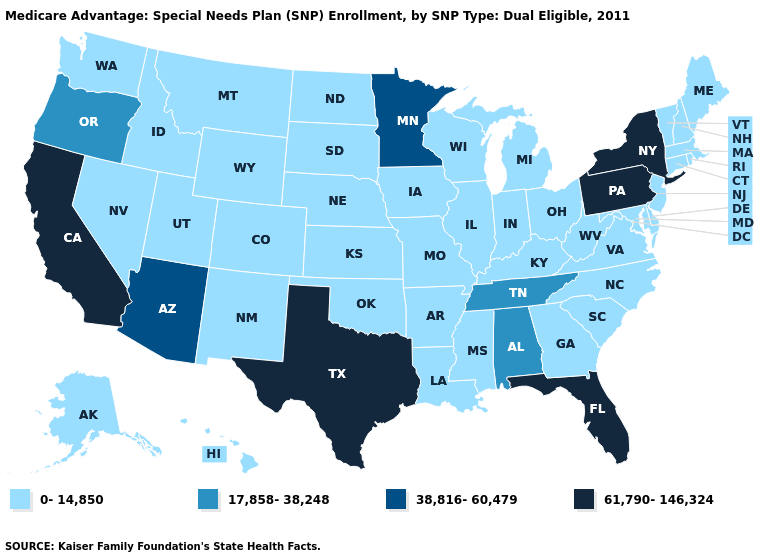Which states have the highest value in the USA?
Quick response, please. California, Florida, New York, Pennsylvania, Texas. Which states have the highest value in the USA?
Keep it brief. California, Florida, New York, Pennsylvania, Texas. Does Pennsylvania have the highest value in the Northeast?
Write a very short answer. Yes. Does North Carolina have a higher value than New Mexico?
Quick response, please. No. Name the states that have a value in the range 17,858-38,248?
Short answer required. Alabama, Oregon, Tennessee. Name the states that have a value in the range 17,858-38,248?
Keep it brief. Alabama, Oregon, Tennessee. Does Ohio have a higher value than Montana?
Keep it brief. No. What is the value of South Dakota?
Give a very brief answer. 0-14,850. What is the highest value in states that border West Virginia?
Short answer required. 61,790-146,324. What is the value of Tennessee?
Quick response, please. 17,858-38,248. Does Nebraska have a lower value than Kansas?
Write a very short answer. No. Name the states that have a value in the range 0-14,850?
Short answer required. Alaska, Arkansas, Colorado, Connecticut, Delaware, Georgia, Hawaii, Iowa, Idaho, Illinois, Indiana, Kansas, Kentucky, Louisiana, Massachusetts, Maryland, Maine, Michigan, Missouri, Mississippi, Montana, North Carolina, North Dakota, Nebraska, New Hampshire, New Jersey, New Mexico, Nevada, Ohio, Oklahoma, Rhode Island, South Carolina, South Dakota, Utah, Virginia, Vermont, Washington, Wisconsin, West Virginia, Wyoming. How many symbols are there in the legend?
Write a very short answer. 4. What is the value of New York?
Concise answer only. 61,790-146,324. Name the states that have a value in the range 0-14,850?
Quick response, please. Alaska, Arkansas, Colorado, Connecticut, Delaware, Georgia, Hawaii, Iowa, Idaho, Illinois, Indiana, Kansas, Kentucky, Louisiana, Massachusetts, Maryland, Maine, Michigan, Missouri, Mississippi, Montana, North Carolina, North Dakota, Nebraska, New Hampshire, New Jersey, New Mexico, Nevada, Ohio, Oklahoma, Rhode Island, South Carolina, South Dakota, Utah, Virginia, Vermont, Washington, Wisconsin, West Virginia, Wyoming. 